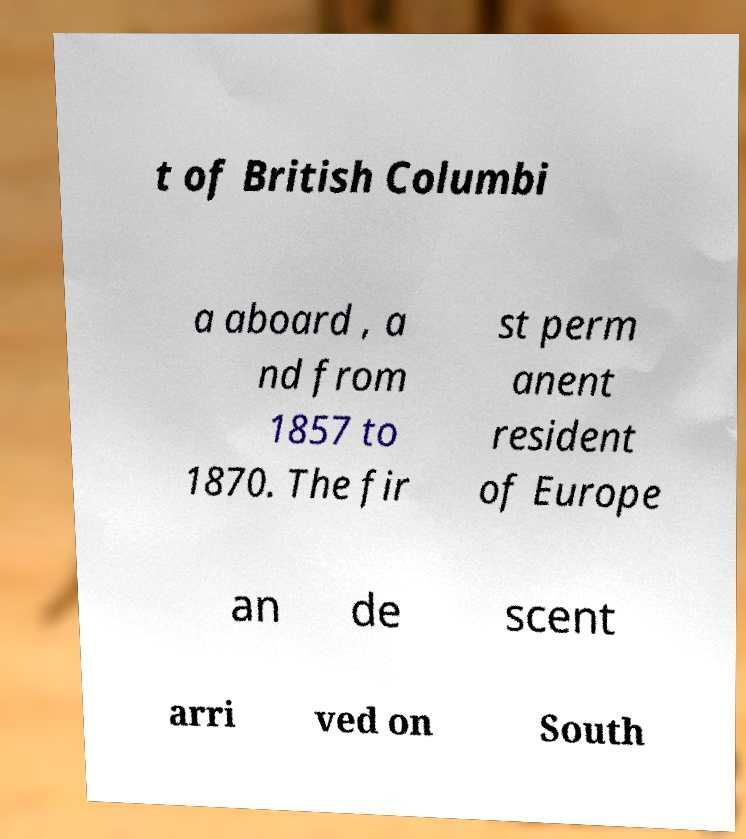Could you extract and type out the text from this image? t of British Columbi a aboard , a nd from 1857 to 1870. The fir st perm anent resident of Europe an de scent arri ved on South 